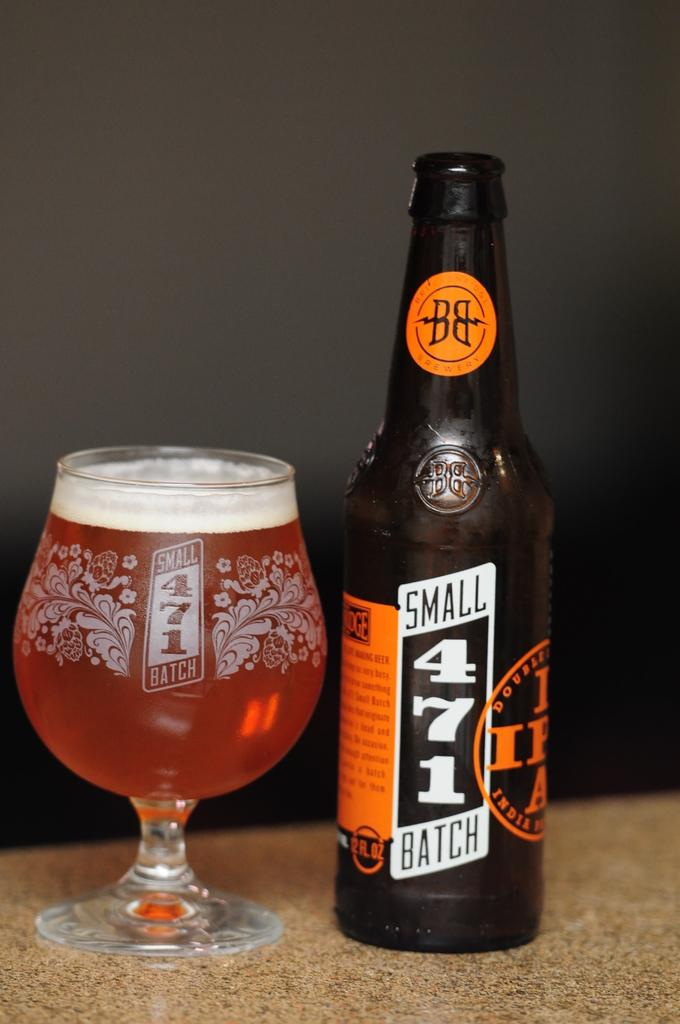What is one of the objects in the image? There is a bottle in the image. What is another object in the image that contains liquid? There is a glass with liquid in the image. On what object are the glass and bottle placed? The glass and bottle are placed on an object. What can be seen in the background of the image? There is a wall visible in the image. What type of sticks can be seen in the image? There are no sticks present in the image. Is there a stranger interacting with the objects in the image? There is no stranger present in the image. 